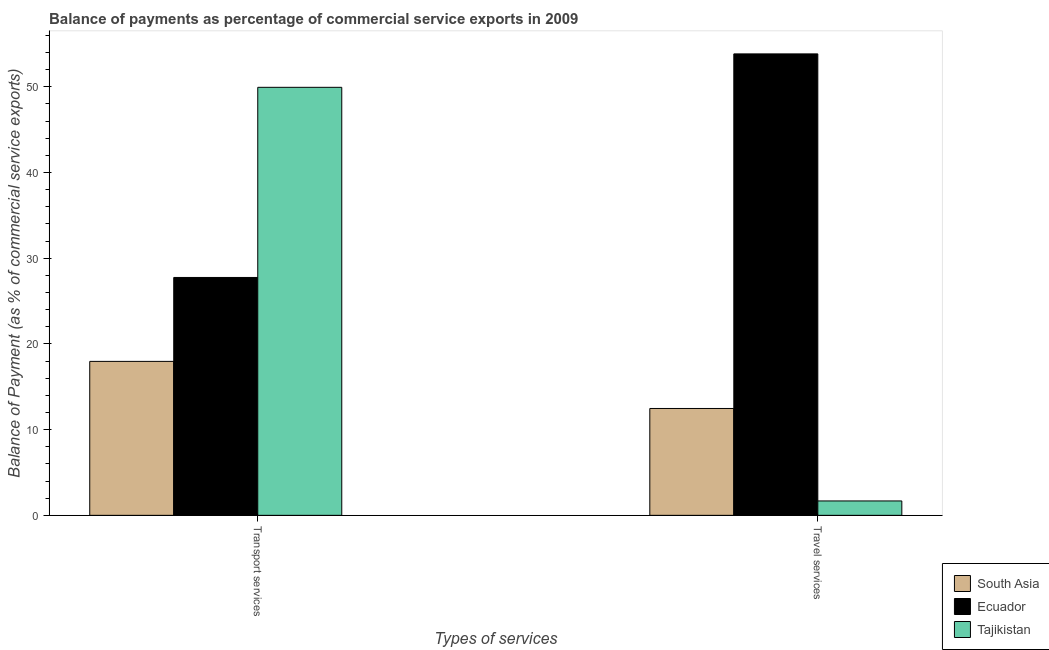How many groups of bars are there?
Offer a very short reply. 2. Are the number of bars on each tick of the X-axis equal?
Give a very brief answer. Yes. What is the label of the 1st group of bars from the left?
Ensure brevity in your answer.  Transport services. What is the balance of payments of travel services in Tajikistan?
Your response must be concise. 1.68. Across all countries, what is the maximum balance of payments of transport services?
Your response must be concise. 49.93. Across all countries, what is the minimum balance of payments of transport services?
Keep it short and to the point. 17.96. In which country was the balance of payments of transport services maximum?
Provide a short and direct response. Tajikistan. In which country was the balance of payments of transport services minimum?
Your answer should be very brief. South Asia. What is the total balance of payments of transport services in the graph?
Ensure brevity in your answer.  95.64. What is the difference between the balance of payments of transport services in South Asia and that in Tajikistan?
Your answer should be compact. -31.97. What is the difference between the balance of payments of travel services in Tajikistan and the balance of payments of transport services in South Asia?
Make the answer very short. -16.28. What is the average balance of payments of transport services per country?
Offer a terse response. 31.88. What is the difference between the balance of payments of transport services and balance of payments of travel services in South Asia?
Make the answer very short. 5.49. What is the ratio of the balance of payments of transport services in South Asia to that in Tajikistan?
Make the answer very short. 0.36. Is the balance of payments of travel services in South Asia less than that in Ecuador?
Your answer should be compact. Yes. What does the 3rd bar from the left in Transport services represents?
Give a very brief answer. Tajikistan. What does the 1st bar from the right in Travel services represents?
Your answer should be very brief. Tajikistan. How many bars are there?
Your answer should be compact. 6. How many legend labels are there?
Provide a succinct answer. 3. What is the title of the graph?
Give a very brief answer. Balance of payments as percentage of commercial service exports in 2009. What is the label or title of the X-axis?
Give a very brief answer. Types of services. What is the label or title of the Y-axis?
Provide a short and direct response. Balance of Payment (as % of commercial service exports). What is the Balance of Payment (as % of commercial service exports) in South Asia in Transport services?
Your response must be concise. 17.96. What is the Balance of Payment (as % of commercial service exports) in Ecuador in Transport services?
Make the answer very short. 27.75. What is the Balance of Payment (as % of commercial service exports) in Tajikistan in Transport services?
Your answer should be compact. 49.93. What is the Balance of Payment (as % of commercial service exports) in South Asia in Travel services?
Make the answer very short. 12.47. What is the Balance of Payment (as % of commercial service exports) of Ecuador in Travel services?
Make the answer very short. 53.83. What is the Balance of Payment (as % of commercial service exports) of Tajikistan in Travel services?
Your answer should be compact. 1.68. Across all Types of services, what is the maximum Balance of Payment (as % of commercial service exports) of South Asia?
Give a very brief answer. 17.96. Across all Types of services, what is the maximum Balance of Payment (as % of commercial service exports) in Ecuador?
Ensure brevity in your answer.  53.83. Across all Types of services, what is the maximum Balance of Payment (as % of commercial service exports) of Tajikistan?
Ensure brevity in your answer.  49.93. Across all Types of services, what is the minimum Balance of Payment (as % of commercial service exports) of South Asia?
Your answer should be very brief. 12.47. Across all Types of services, what is the minimum Balance of Payment (as % of commercial service exports) of Ecuador?
Keep it short and to the point. 27.75. Across all Types of services, what is the minimum Balance of Payment (as % of commercial service exports) in Tajikistan?
Make the answer very short. 1.68. What is the total Balance of Payment (as % of commercial service exports) in South Asia in the graph?
Offer a terse response. 30.43. What is the total Balance of Payment (as % of commercial service exports) of Ecuador in the graph?
Offer a very short reply. 81.58. What is the total Balance of Payment (as % of commercial service exports) in Tajikistan in the graph?
Offer a terse response. 51.61. What is the difference between the Balance of Payment (as % of commercial service exports) in South Asia in Transport services and that in Travel services?
Your response must be concise. 5.49. What is the difference between the Balance of Payment (as % of commercial service exports) of Ecuador in Transport services and that in Travel services?
Provide a succinct answer. -26.08. What is the difference between the Balance of Payment (as % of commercial service exports) in Tajikistan in Transport services and that in Travel services?
Give a very brief answer. 48.25. What is the difference between the Balance of Payment (as % of commercial service exports) in South Asia in Transport services and the Balance of Payment (as % of commercial service exports) in Ecuador in Travel services?
Ensure brevity in your answer.  -35.87. What is the difference between the Balance of Payment (as % of commercial service exports) of South Asia in Transport services and the Balance of Payment (as % of commercial service exports) of Tajikistan in Travel services?
Offer a terse response. 16.28. What is the difference between the Balance of Payment (as % of commercial service exports) of Ecuador in Transport services and the Balance of Payment (as % of commercial service exports) of Tajikistan in Travel services?
Your answer should be very brief. 26.07. What is the average Balance of Payment (as % of commercial service exports) in South Asia per Types of services?
Offer a very short reply. 15.21. What is the average Balance of Payment (as % of commercial service exports) of Ecuador per Types of services?
Offer a very short reply. 40.79. What is the average Balance of Payment (as % of commercial service exports) of Tajikistan per Types of services?
Offer a very short reply. 25.81. What is the difference between the Balance of Payment (as % of commercial service exports) in South Asia and Balance of Payment (as % of commercial service exports) in Ecuador in Transport services?
Your answer should be compact. -9.79. What is the difference between the Balance of Payment (as % of commercial service exports) in South Asia and Balance of Payment (as % of commercial service exports) in Tajikistan in Transport services?
Ensure brevity in your answer.  -31.97. What is the difference between the Balance of Payment (as % of commercial service exports) in Ecuador and Balance of Payment (as % of commercial service exports) in Tajikistan in Transport services?
Keep it short and to the point. -22.18. What is the difference between the Balance of Payment (as % of commercial service exports) of South Asia and Balance of Payment (as % of commercial service exports) of Ecuador in Travel services?
Offer a terse response. -41.37. What is the difference between the Balance of Payment (as % of commercial service exports) of South Asia and Balance of Payment (as % of commercial service exports) of Tajikistan in Travel services?
Your response must be concise. 10.79. What is the difference between the Balance of Payment (as % of commercial service exports) of Ecuador and Balance of Payment (as % of commercial service exports) of Tajikistan in Travel services?
Give a very brief answer. 52.15. What is the ratio of the Balance of Payment (as % of commercial service exports) in South Asia in Transport services to that in Travel services?
Provide a succinct answer. 1.44. What is the ratio of the Balance of Payment (as % of commercial service exports) of Ecuador in Transport services to that in Travel services?
Offer a terse response. 0.52. What is the ratio of the Balance of Payment (as % of commercial service exports) in Tajikistan in Transport services to that in Travel services?
Ensure brevity in your answer.  29.73. What is the difference between the highest and the second highest Balance of Payment (as % of commercial service exports) in South Asia?
Offer a very short reply. 5.49. What is the difference between the highest and the second highest Balance of Payment (as % of commercial service exports) in Ecuador?
Your answer should be very brief. 26.08. What is the difference between the highest and the second highest Balance of Payment (as % of commercial service exports) of Tajikistan?
Your answer should be very brief. 48.25. What is the difference between the highest and the lowest Balance of Payment (as % of commercial service exports) of South Asia?
Your answer should be very brief. 5.49. What is the difference between the highest and the lowest Balance of Payment (as % of commercial service exports) in Ecuador?
Your response must be concise. 26.08. What is the difference between the highest and the lowest Balance of Payment (as % of commercial service exports) of Tajikistan?
Offer a terse response. 48.25. 